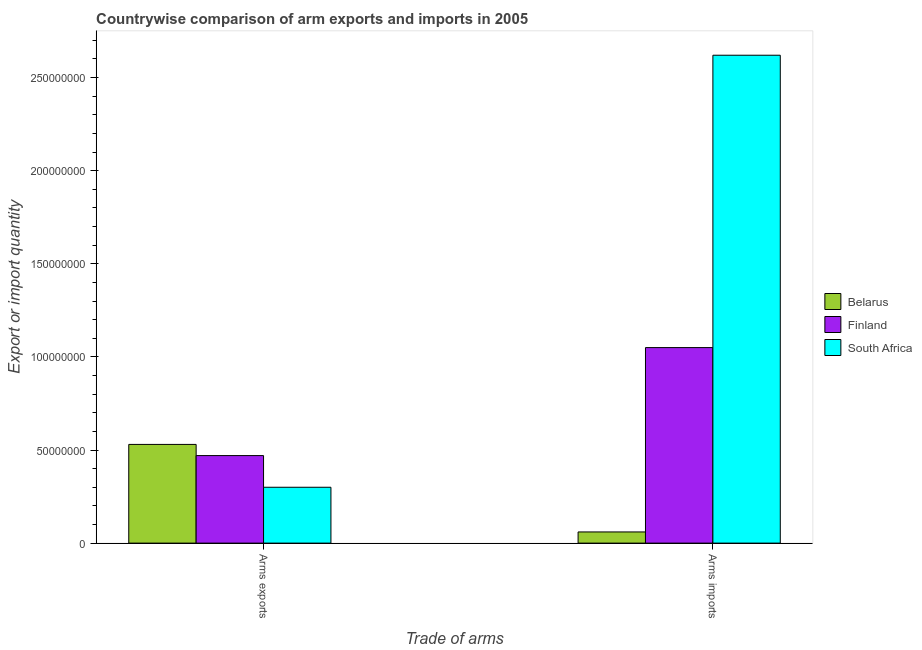How many groups of bars are there?
Keep it short and to the point. 2. Are the number of bars per tick equal to the number of legend labels?
Provide a short and direct response. Yes. Are the number of bars on each tick of the X-axis equal?
Ensure brevity in your answer.  Yes. How many bars are there on the 1st tick from the right?
Give a very brief answer. 3. What is the label of the 2nd group of bars from the left?
Offer a terse response. Arms imports. What is the arms imports in Belarus?
Offer a terse response. 6.00e+06. Across all countries, what is the maximum arms imports?
Provide a succinct answer. 2.62e+08. Across all countries, what is the minimum arms imports?
Give a very brief answer. 6.00e+06. In which country was the arms imports maximum?
Offer a terse response. South Africa. In which country was the arms exports minimum?
Give a very brief answer. South Africa. What is the total arms exports in the graph?
Provide a short and direct response. 1.30e+08. What is the difference between the arms exports in Belarus and that in South Africa?
Ensure brevity in your answer.  2.30e+07. What is the difference between the arms exports in South Africa and the arms imports in Finland?
Keep it short and to the point. -7.50e+07. What is the average arms exports per country?
Keep it short and to the point. 4.33e+07. What is the difference between the arms imports and arms exports in Belarus?
Your answer should be compact. -4.70e+07. In how many countries, is the arms imports greater than 20000000 ?
Make the answer very short. 2. What is the ratio of the arms imports in Finland to that in Belarus?
Offer a terse response. 17.5. In how many countries, is the arms exports greater than the average arms exports taken over all countries?
Your answer should be very brief. 2. What does the 3rd bar from the left in Arms imports represents?
Offer a very short reply. South Africa. What does the 3rd bar from the right in Arms imports represents?
Ensure brevity in your answer.  Belarus. How many bars are there?
Your answer should be very brief. 6. Are all the bars in the graph horizontal?
Your answer should be very brief. No. How many countries are there in the graph?
Give a very brief answer. 3. What is the difference between two consecutive major ticks on the Y-axis?
Offer a terse response. 5.00e+07. Are the values on the major ticks of Y-axis written in scientific E-notation?
Your response must be concise. No. Does the graph contain grids?
Offer a very short reply. No. How many legend labels are there?
Keep it short and to the point. 3. How are the legend labels stacked?
Ensure brevity in your answer.  Vertical. What is the title of the graph?
Your response must be concise. Countrywise comparison of arm exports and imports in 2005. Does "Burundi" appear as one of the legend labels in the graph?
Offer a very short reply. No. What is the label or title of the X-axis?
Keep it short and to the point. Trade of arms. What is the label or title of the Y-axis?
Give a very brief answer. Export or import quantity. What is the Export or import quantity of Belarus in Arms exports?
Keep it short and to the point. 5.30e+07. What is the Export or import quantity in Finland in Arms exports?
Your response must be concise. 4.70e+07. What is the Export or import quantity of South Africa in Arms exports?
Provide a succinct answer. 3.00e+07. What is the Export or import quantity in Finland in Arms imports?
Offer a terse response. 1.05e+08. What is the Export or import quantity of South Africa in Arms imports?
Keep it short and to the point. 2.62e+08. Across all Trade of arms, what is the maximum Export or import quantity in Belarus?
Offer a terse response. 5.30e+07. Across all Trade of arms, what is the maximum Export or import quantity in Finland?
Your answer should be compact. 1.05e+08. Across all Trade of arms, what is the maximum Export or import quantity of South Africa?
Ensure brevity in your answer.  2.62e+08. Across all Trade of arms, what is the minimum Export or import quantity of Finland?
Ensure brevity in your answer.  4.70e+07. Across all Trade of arms, what is the minimum Export or import quantity of South Africa?
Keep it short and to the point. 3.00e+07. What is the total Export or import quantity of Belarus in the graph?
Your answer should be compact. 5.90e+07. What is the total Export or import quantity in Finland in the graph?
Your response must be concise. 1.52e+08. What is the total Export or import quantity of South Africa in the graph?
Your answer should be compact. 2.92e+08. What is the difference between the Export or import quantity in Belarus in Arms exports and that in Arms imports?
Keep it short and to the point. 4.70e+07. What is the difference between the Export or import quantity of Finland in Arms exports and that in Arms imports?
Offer a very short reply. -5.80e+07. What is the difference between the Export or import quantity in South Africa in Arms exports and that in Arms imports?
Offer a very short reply. -2.32e+08. What is the difference between the Export or import quantity in Belarus in Arms exports and the Export or import quantity in Finland in Arms imports?
Your response must be concise. -5.20e+07. What is the difference between the Export or import quantity in Belarus in Arms exports and the Export or import quantity in South Africa in Arms imports?
Make the answer very short. -2.09e+08. What is the difference between the Export or import quantity in Finland in Arms exports and the Export or import quantity in South Africa in Arms imports?
Offer a terse response. -2.15e+08. What is the average Export or import quantity in Belarus per Trade of arms?
Provide a succinct answer. 2.95e+07. What is the average Export or import quantity in Finland per Trade of arms?
Your answer should be very brief. 7.60e+07. What is the average Export or import quantity in South Africa per Trade of arms?
Your answer should be compact. 1.46e+08. What is the difference between the Export or import quantity in Belarus and Export or import quantity in South Africa in Arms exports?
Give a very brief answer. 2.30e+07. What is the difference between the Export or import quantity in Finland and Export or import quantity in South Africa in Arms exports?
Your answer should be compact. 1.70e+07. What is the difference between the Export or import quantity in Belarus and Export or import quantity in Finland in Arms imports?
Your answer should be compact. -9.90e+07. What is the difference between the Export or import quantity in Belarus and Export or import quantity in South Africa in Arms imports?
Give a very brief answer. -2.56e+08. What is the difference between the Export or import quantity in Finland and Export or import quantity in South Africa in Arms imports?
Your response must be concise. -1.57e+08. What is the ratio of the Export or import quantity in Belarus in Arms exports to that in Arms imports?
Offer a very short reply. 8.83. What is the ratio of the Export or import quantity of Finland in Arms exports to that in Arms imports?
Give a very brief answer. 0.45. What is the ratio of the Export or import quantity of South Africa in Arms exports to that in Arms imports?
Provide a short and direct response. 0.11. What is the difference between the highest and the second highest Export or import quantity in Belarus?
Make the answer very short. 4.70e+07. What is the difference between the highest and the second highest Export or import quantity of Finland?
Provide a short and direct response. 5.80e+07. What is the difference between the highest and the second highest Export or import quantity in South Africa?
Make the answer very short. 2.32e+08. What is the difference between the highest and the lowest Export or import quantity in Belarus?
Provide a succinct answer. 4.70e+07. What is the difference between the highest and the lowest Export or import quantity of Finland?
Offer a terse response. 5.80e+07. What is the difference between the highest and the lowest Export or import quantity in South Africa?
Your answer should be very brief. 2.32e+08. 